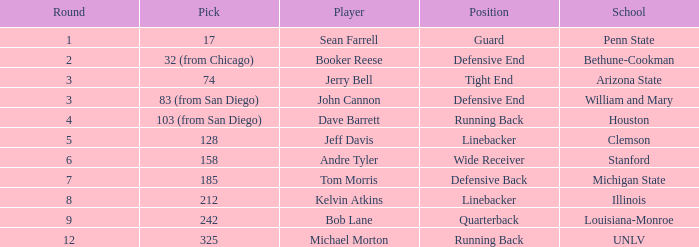Would you be able to parse every entry in this table? {'header': ['Round', 'Pick', 'Player', 'Position', 'School'], 'rows': [['1', '17', 'Sean Farrell', 'Guard', 'Penn State'], ['2', '32 (from Chicago)', 'Booker Reese', 'Defensive End', 'Bethune-Cookman'], ['3', '74', 'Jerry Bell', 'Tight End', 'Arizona State'], ['3', '83 (from San Diego)', 'John Cannon', 'Defensive End', 'William and Mary'], ['4', '103 (from San Diego)', 'Dave Barrett', 'Running Back', 'Houston'], ['5', '128', 'Jeff Davis', 'Linebacker', 'Clemson'], ['6', '158', 'Andre Tyler', 'Wide Receiver', 'Stanford'], ['7', '185', 'Tom Morris', 'Defensive Back', 'Michigan State'], ['8', '212', 'Kelvin Atkins', 'Linebacker', 'Illinois'], ['9', '242', 'Bob Lane', 'Quarterback', 'Louisiana-Monroe'], ['12', '325', 'Michael Morton', 'Running Back', 'UNLV']]} Which round was Tom Morris picked in? 1.0. 